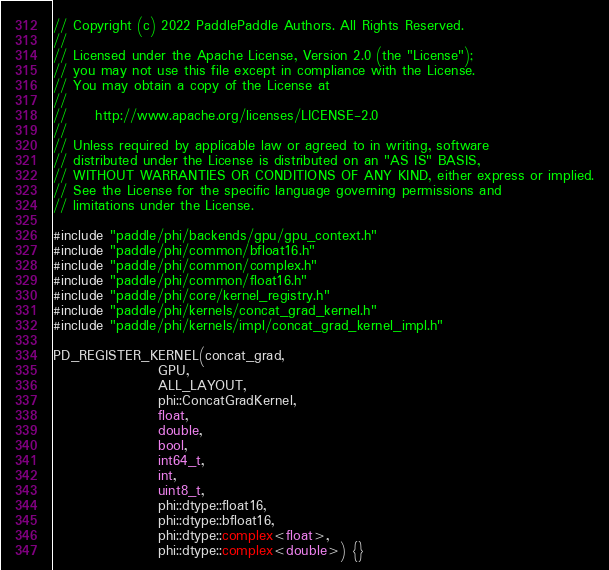<code> <loc_0><loc_0><loc_500><loc_500><_Cuda_>// Copyright (c) 2022 PaddlePaddle Authors. All Rights Reserved.
//
// Licensed under the Apache License, Version 2.0 (the "License");
// you may not use this file except in compliance with the License.
// You may obtain a copy of the License at
//
//     http://www.apache.org/licenses/LICENSE-2.0
//
// Unless required by applicable law or agreed to in writing, software
// distributed under the License is distributed on an "AS IS" BASIS,
// WITHOUT WARRANTIES OR CONDITIONS OF ANY KIND, either express or implied.
// See the License for the specific language governing permissions and
// limitations under the License.

#include "paddle/phi/backends/gpu/gpu_context.h"
#include "paddle/phi/common/bfloat16.h"
#include "paddle/phi/common/complex.h"
#include "paddle/phi/common/float16.h"
#include "paddle/phi/core/kernel_registry.h"
#include "paddle/phi/kernels/concat_grad_kernel.h"
#include "paddle/phi/kernels/impl/concat_grad_kernel_impl.h"

PD_REGISTER_KERNEL(concat_grad,
                   GPU,
                   ALL_LAYOUT,
                   phi::ConcatGradKernel,
                   float,
                   double,
                   bool,
                   int64_t,
                   int,
                   uint8_t,
                   phi::dtype::float16,
                   phi::dtype::bfloat16,
                   phi::dtype::complex<float>,
                   phi::dtype::complex<double>) {}
</code> 